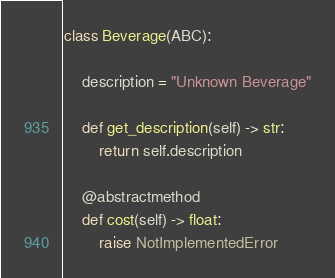<code> <loc_0><loc_0><loc_500><loc_500><_Python_>class Beverage(ABC):

    description = "Unknown Beverage"

    def get_description(self) -> str:
        return self.description

    @abstractmethod
    def cost(self) -> float:
        raise NotImplementedError
</code> 